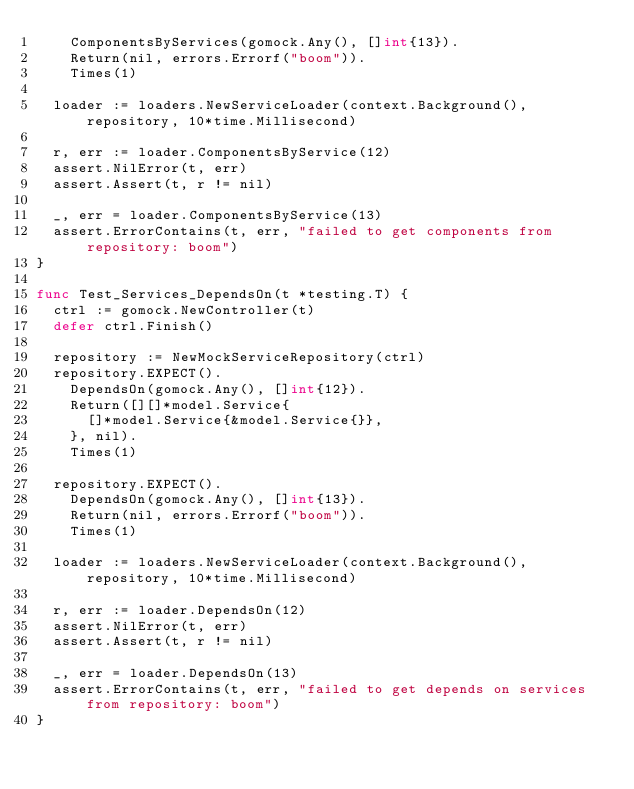Convert code to text. <code><loc_0><loc_0><loc_500><loc_500><_Go_>		ComponentsByServices(gomock.Any(), []int{13}).
		Return(nil, errors.Errorf("boom")).
		Times(1)

	loader := loaders.NewServiceLoader(context.Background(), repository, 10*time.Millisecond)

	r, err := loader.ComponentsByService(12)
	assert.NilError(t, err)
	assert.Assert(t, r != nil)

	_, err = loader.ComponentsByService(13)
	assert.ErrorContains(t, err, "failed to get components from repository: boom")
}

func Test_Services_DependsOn(t *testing.T) {
	ctrl := gomock.NewController(t)
	defer ctrl.Finish()

	repository := NewMockServiceRepository(ctrl)
	repository.EXPECT().
		DependsOn(gomock.Any(), []int{12}).
		Return([][]*model.Service{
			[]*model.Service{&model.Service{}},
		}, nil).
		Times(1)

	repository.EXPECT().
		DependsOn(gomock.Any(), []int{13}).
		Return(nil, errors.Errorf("boom")).
		Times(1)

	loader := loaders.NewServiceLoader(context.Background(), repository, 10*time.Millisecond)

	r, err := loader.DependsOn(12)
	assert.NilError(t, err)
	assert.Assert(t, r != nil)

	_, err = loader.DependsOn(13)
	assert.ErrorContains(t, err, "failed to get depends on services from repository: boom")
}
</code> 